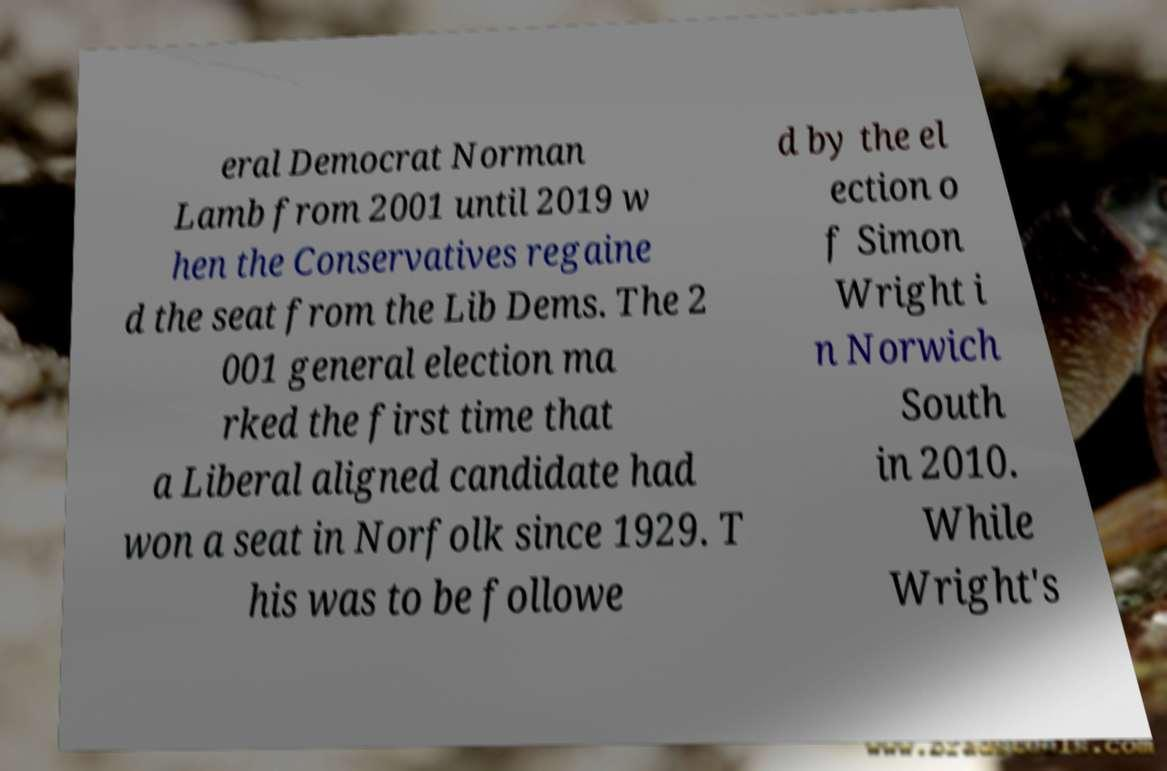Please identify and transcribe the text found in this image. eral Democrat Norman Lamb from 2001 until 2019 w hen the Conservatives regaine d the seat from the Lib Dems. The 2 001 general election ma rked the first time that a Liberal aligned candidate had won a seat in Norfolk since 1929. T his was to be followe d by the el ection o f Simon Wright i n Norwich South in 2010. While Wright's 